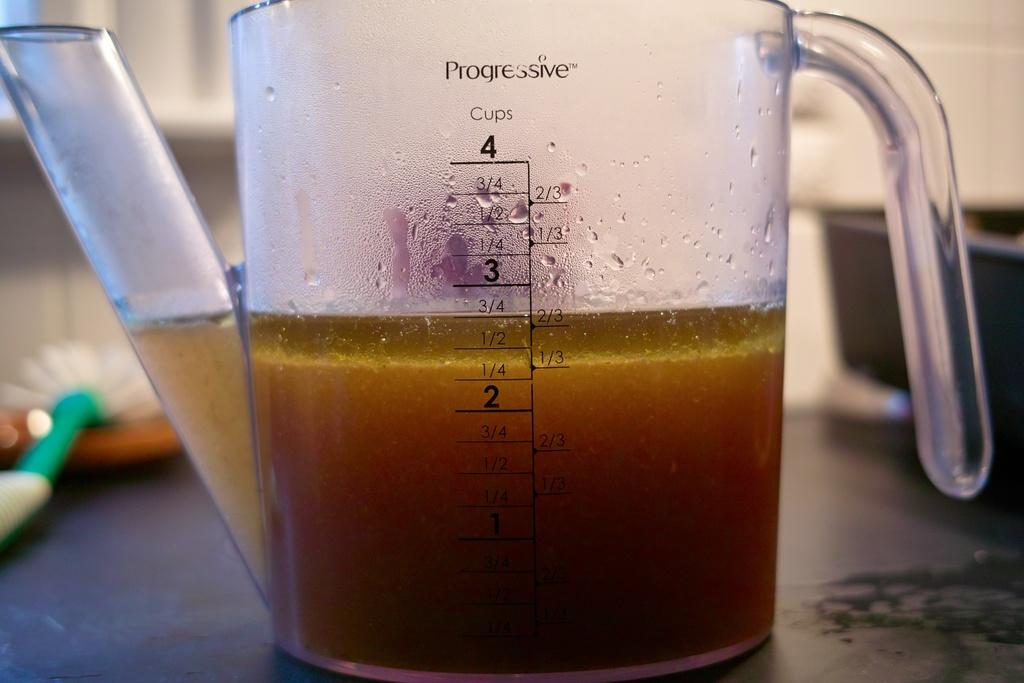<image>
Render a clear and concise summary of the photo. progressive 4 cup measuring cup with 2 3/4 cups of yellowish-brown liquid in it. 